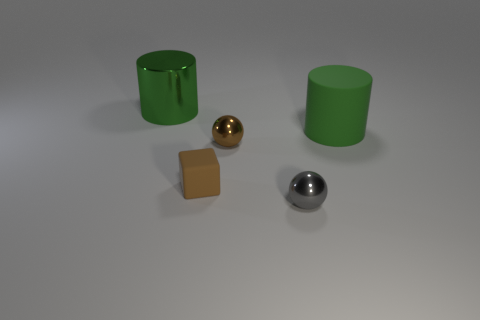The thing that is the same color as the large rubber cylinder is what shape?
Your answer should be very brief. Cylinder. There is a brown rubber thing that is in front of the large cylinder that is on the left side of the tiny brown object behind the matte cube; what is its size?
Your response must be concise. Small. What material is the object that is the same color as the tiny matte cube?
Your answer should be very brief. Metal. Is there anything else that has the same shape as the tiny rubber object?
Offer a very short reply. No. There is a metallic sphere that is right of the small brown object that is right of the small brown rubber block; how big is it?
Offer a terse response. Small. What number of small things are either brown things or rubber cylinders?
Offer a very short reply. 2. Is the number of gray metal spheres less than the number of matte things?
Make the answer very short. Yes. Is the big shiny thing the same color as the rubber cylinder?
Keep it short and to the point. Yes. Are there more small brown objects than things?
Keep it short and to the point. No. What number of other things are there of the same color as the small rubber cube?
Keep it short and to the point. 1. 